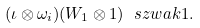<formula> <loc_0><loc_0><loc_500><loc_500>( \iota \otimes \omega _ { i } ) ( W _ { 1 } \otimes 1 ) \ s z w a k 1 .</formula> 